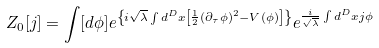Convert formula to latex. <formula><loc_0><loc_0><loc_500><loc_500>Z _ { 0 } [ j ] = \int [ d \phi ] e ^ { \left \{ i \sqrt { \lambda } \int d ^ { D } x \left [ \frac { 1 } { 2 } ( \partial _ { \tau } \phi ) ^ { 2 } - V ( \phi ) \right ] \right \} } e ^ { \frac { i } { \sqrt { \lambda } } \int d ^ { D } x j \phi }</formula> 